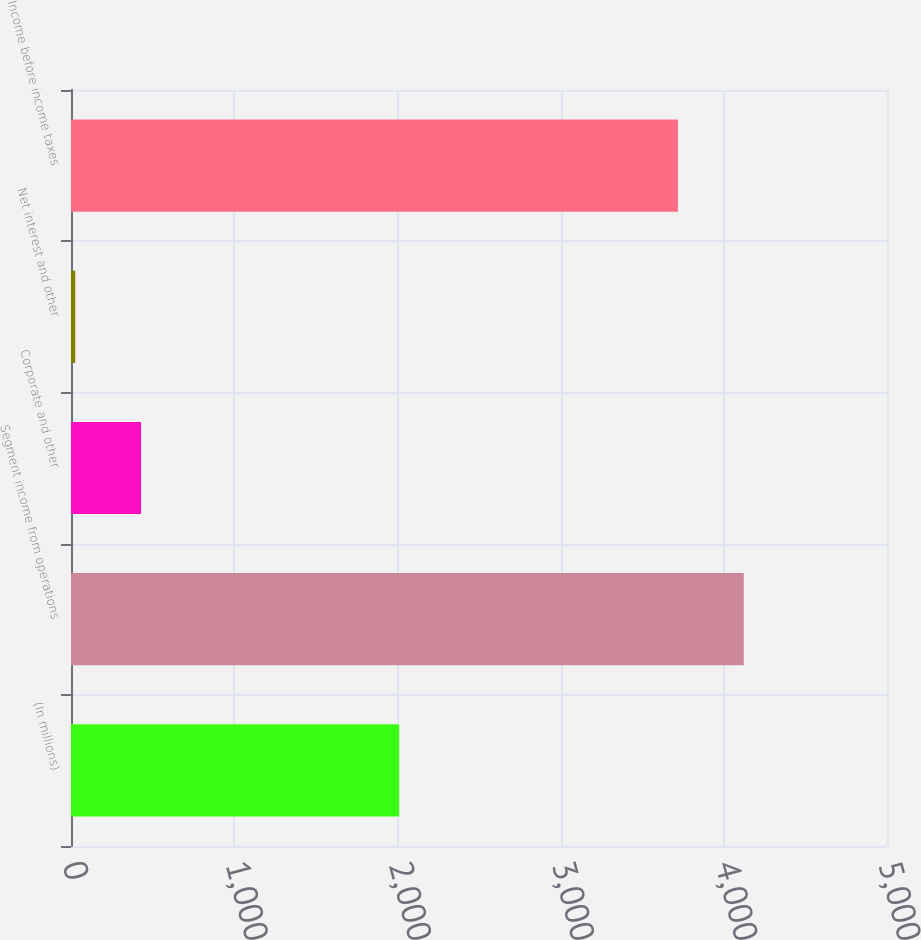Convert chart. <chart><loc_0><loc_0><loc_500><loc_500><bar_chart><fcel>(In millions)<fcel>Segment income from operations<fcel>Corporate and other<fcel>Net interest and other<fcel>Income before income taxes<nl><fcel>2011<fcel>4122.5<fcel>429.5<fcel>26<fcel>3719<nl></chart> 